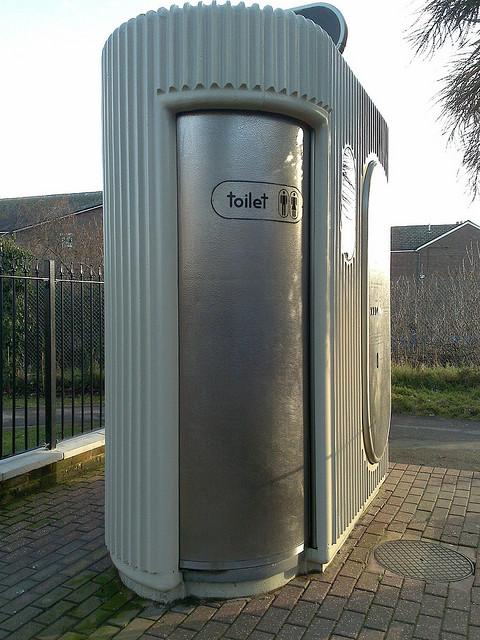Is it sunny?
Be succinct. Yes. What does the sign on the door said?
Write a very short answer. Toilet. What is the fence made out of?
Concise answer only. Metal. 